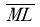<formula> <loc_0><loc_0><loc_500><loc_500>\overline { M L }</formula> 